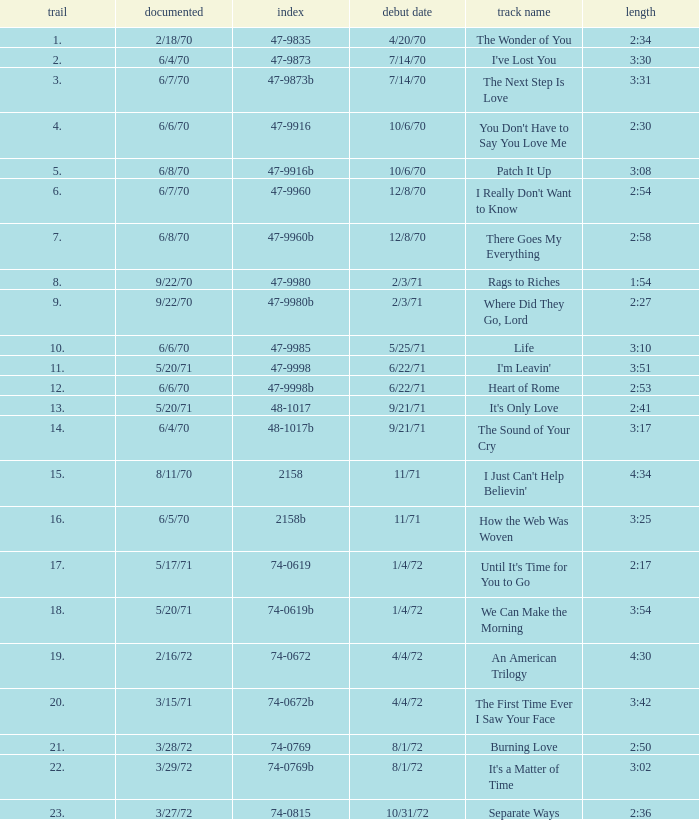What is Heart of Rome's catalogue number? 47-9998b. 